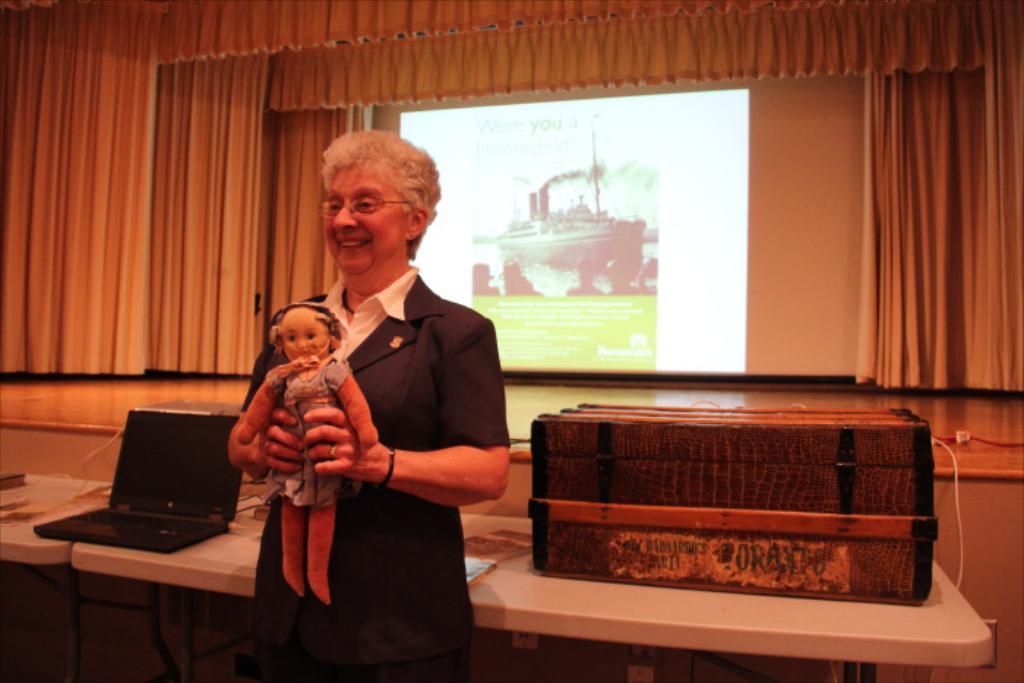Describe this image in one or two sentences. In this image we can see a stage, a projector screen and few curtains. There are many objects placed on the table. A lady is standing and holding a toy in the image. 